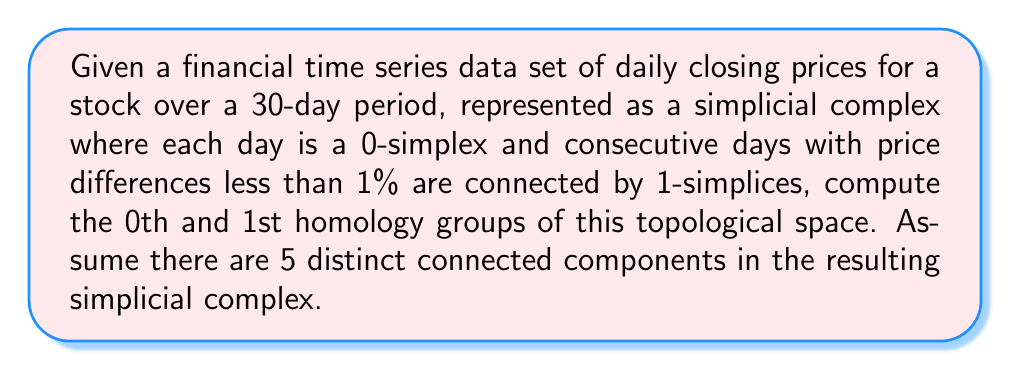Teach me how to tackle this problem. To compute the homology groups of this financial time series data set, we need to understand the structure of the simplicial complex and apply the concepts of algebraic topology. Let's break this down step-by-step:

1. Structure of the simplicial complex:
   - 0-simplices: 30 points, each representing a day
   - 1-simplices: Edges connecting consecutive days with price differences < 1%
   - No higher-dimensional simplices

2. Computing the 0th homology group $H_0$:
   - $H_0$ represents the number of connected components in the space
   - We are given that there are 5 distinct connected components
   - Therefore, $H_0 \cong \mathbb{Z}^5$ (5 copies of the integers)

3. Computing the 1st homology group $H_1$:
   - $H_1$ represents the number of 1-dimensional holes (loops) in the space
   - In this case, we need to consider the possibility of loops formed by the 1-simplices
   - However, since the 1-simplices only connect consecutive days, it's impossible to form any loops
   - There are no 2-simplices or higher, so there can't be any boundaries of higher-dimensional simplices
   - Therefore, $H_1 \cong 0$ (the trivial group)

4. Higher homology groups:
   - Since there are no simplices of dimension 2 or higher, all homology groups $H_n$ for $n \geq 2$ are trivial: $H_n \cong 0$ for $n \geq 2$

The homology groups provide information about the topological features of the financial time series:
- $H_0$ indicates the number of distinct trends or regimes in the 30-day period
- The trivial $H_1$ suggests no cyclic behavior in the price movements (at the given scale of 1% price differences)
Answer: The homology groups of the financial time series data set are:

$$H_0 \cong \mathbb{Z}^5$$
$$H_1 \cong 0$$
$$H_n \cong 0 \text{ for } n \geq 2$$ 